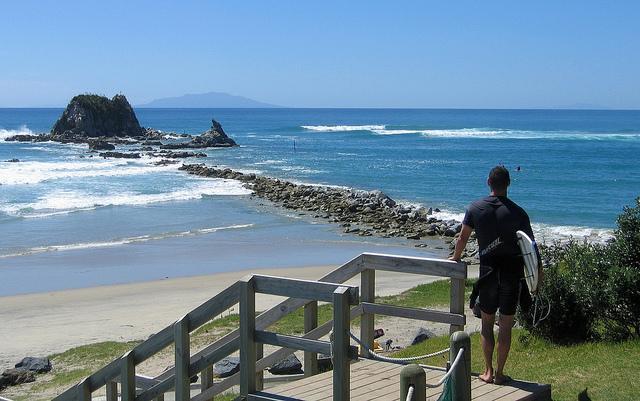How many people in picture?
Give a very brief answer. 1. How many black dog in the image?
Give a very brief answer. 0. 